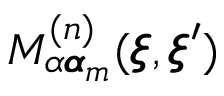Convert formula to latex. <formula><loc_0><loc_0><loc_500><loc_500>M _ { \alpha { \pm b \alpha } _ { m } } ^ { ( n ) } ( { \pm b \xi } , { \pm b \xi } ^ { \prime } )</formula> 